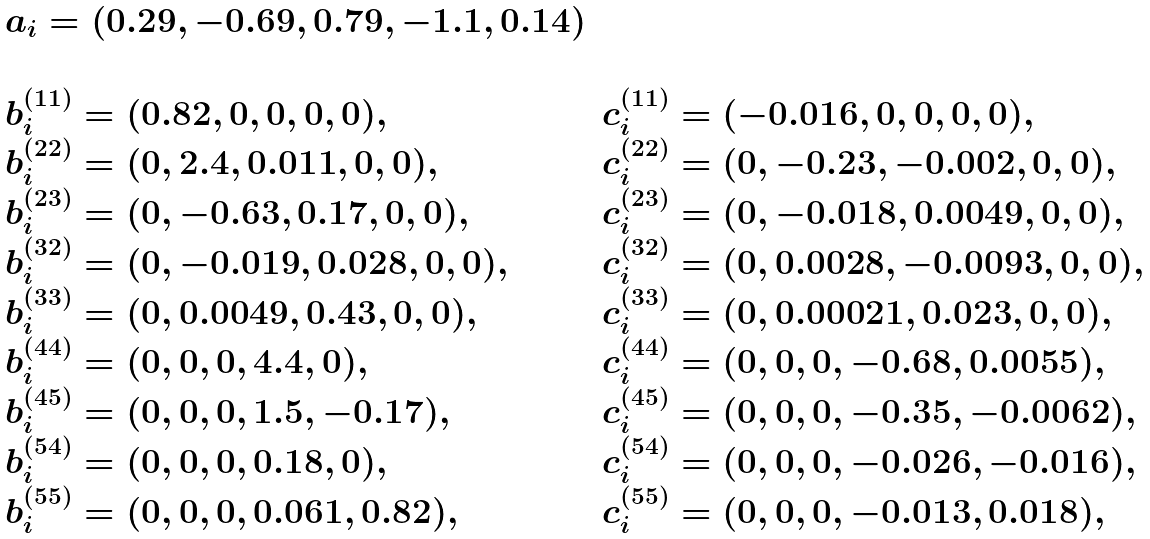Convert formula to latex. <formula><loc_0><loc_0><loc_500><loc_500>\begin{array} { l l } a _ { i } = ( 0 . 2 9 , - 0 . 6 9 , 0 . 7 9 , - 1 . 1 , 0 . 1 4 ) & \\ & \\ b ^ { ( 1 1 ) } _ { i } = ( 0 . 8 2 , 0 , 0 , 0 , 0 ) , & c ^ { ( 1 1 ) } _ { i } = ( - 0 . 0 1 6 , 0 , 0 , 0 , 0 ) , \\ b ^ { ( 2 2 ) } _ { i } = ( 0 , 2 . 4 , 0 . 0 1 1 , 0 , 0 ) , & c ^ { ( 2 2 ) } _ { i } = ( 0 , - 0 . 2 3 , - 0 . 0 0 2 , 0 , 0 ) , \\ b ^ { ( 2 3 ) } _ { i } = ( 0 , - 0 . 6 3 , 0 . 1 7 , 0 , 0 ) , & c ^ { ( 2 3 ) } _ { i } = ( 0 , - 0 . 0 1 8 , 0 . 0 0 4 9 , 0 , 0 ) , \\ b ^ { ( 3 2 ) } _ { i } = ( 0 , - 0 . 0 1 9 , 0 . 0 2 8 , 0 , 0 ) , & c ^ { ( 3 2 ) } _ { i } = ( 0 , 0 . 0 0 2 8 , - 0 . 0 0 9 3 , 0 , 0 ) , \\ b ^ { ( 3 3 ) } _ { i } = ( 0 , 0 . 0 0 4 9 , 0 . 4 3 , 0 , 0 ) , & c ^ { ( 3 3 ) } _ { i } = ( 0 , 0 . 0 0 0 2 1 , 0 . 0 2 3 , 0 , 0 ) , \\ b ^ { ( 4 4 ) } _ { i } = ( 0 , 0 , 0 , 4 . 4 , 0 ) , & c ^ { ( 4 4 ) } _ { i } = ( 0 , 0 , 0 , - 0 . 6 8 , 0 . 0 0 5 5 ) , \\ b ^ { ( 4 5 ) } _ { i } = ( 0 , 0 , 0 , 1 . 5 , - 0 . 1 7 ) , & c ^ { ( 4 5 ) } _ { i } = ( 0 , 0 , 0 , - 0 . 3 5 , - 0 . 0 0 6 2 ) , \\ b ^ { ( 5 4 ) } _ { i } = ( 0 , 0 , 0 , 0 . 1 8 , 0 ) , & c ^ { ( 5 4 ) } _ { i } = ( 0 , 0 , 0 , - 0 . 0 2 6 , - 0 . 0 1 6 ) , \\ b ^ { ( 5 5 ) } _ { i } = ( 0 , 0 , 0 , 0 . 0 6 1 , 0 . 8 2 ) , & c ^ { ( 5 5 ) } _ { i } = ( 0 , 0 , 0 , - 0 . 0 1 3 , 0 . 0 1 8 ) , \\ \end{array}</formula> 